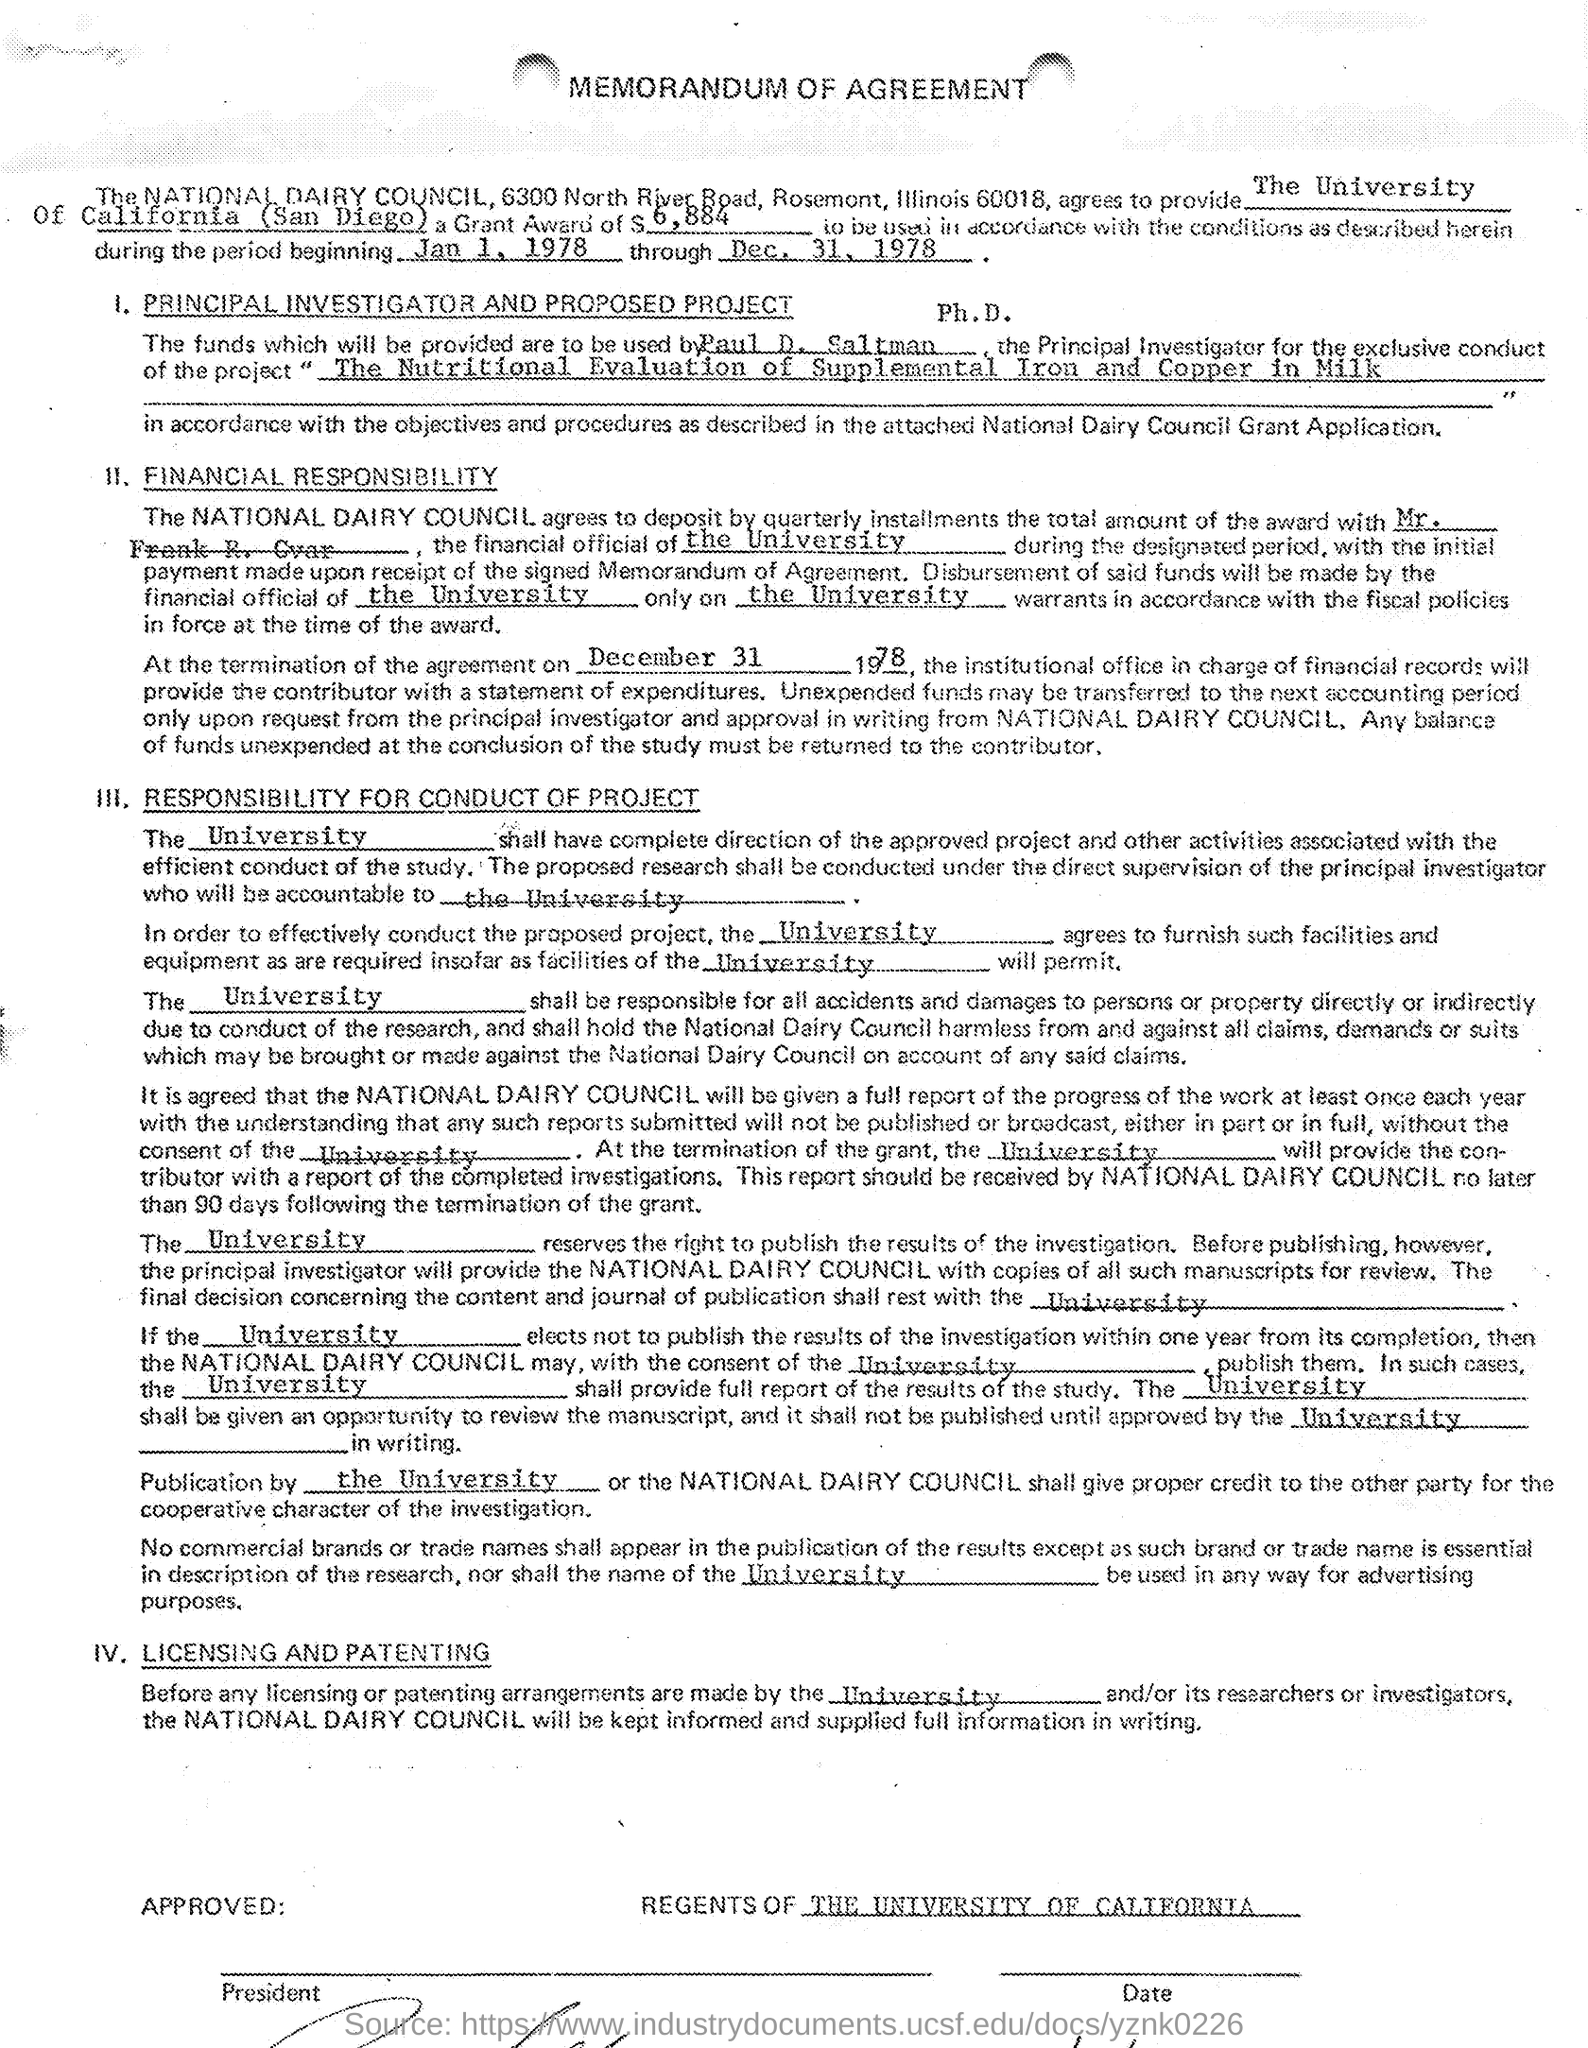Which university got National Dairy council provided Grant award?
Provide a short and direct response. The University of California (San Diego). Whats the amount Awarded?
Give a very brief answer. $ 6,884. Whats  duration mentioned to use the funds?
Provide a succinct answer. Jan 1, 1978 through Dec 31, 1978. Whats the name of Project where these funds used?
Ensure brevity in your answer.  The Nutritional Evaluation of Supplemental Iron and Copper in Milk. 